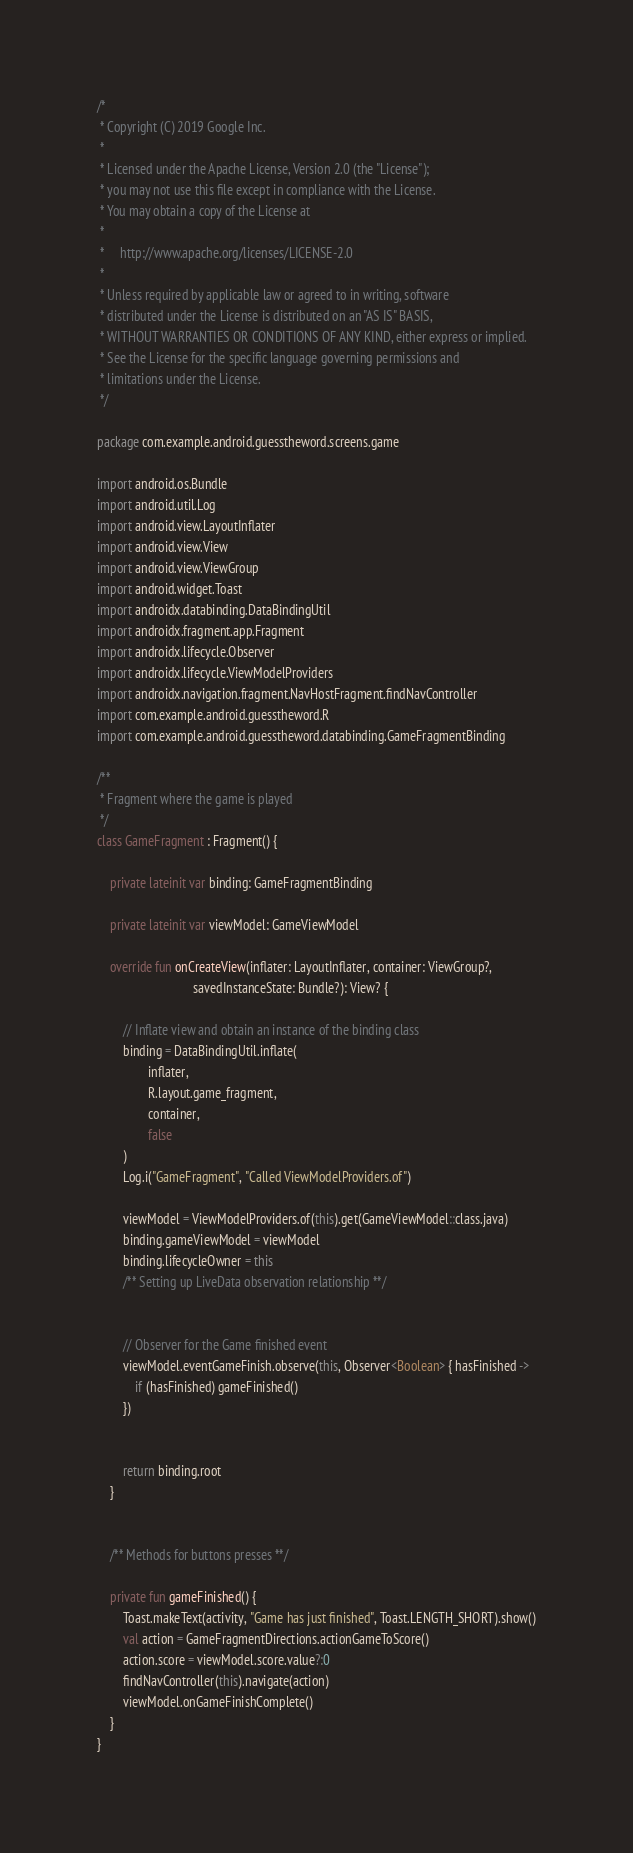Convert code to text. <code><loc_0><loc_0><loc_500><loc_500><_Kotlin_>/*
 * Copyright (C) 2019 Google Inc.
 *
 * Licensed under the Apache License, Version 2.0 (the "License");
 * you may not use this file except in compliance with the License.
 * You may obtain a copy of the License at
 *
 *     http://www.apache.org/licenses/LICENSE-2.0
 *
 * Unless required by applicable law or agreed to in writing, software
 * distributed under the License is distributed on an "AS IS" BASIS,
 * WITHOUT WARRANTIES OR CONDITIONS OF ANY KIND, either express or implied.
 * See the License for the specific language governing permissions and
 * limitations under the License.
 */

package com.example.android.guesstheword.screens.game

import android.os.Bundle
import android.util.Log
import android.view.LayoutInflater
import android.view.View
import android.view.ViewGroup
import android.widget.Toast
import androidx.databinding.DataBindingUtil
import androidx.fragment.app.Fragment
import androidx.lifecycle.Observer
import androidx.lifecycle.ViewModelProviders
import androidx.navigation.fragment.NavHostFragment.findNavController
import com.example.android.guesstheword.R
import com.example.android.guesstheword.databinding.GameFragmentBinding

/**
 * Fragment where the game is played
 */
class GameFragment : Fragment() {

    private lateinit var binding: GameFragmentBinding

    private lateinit var viewModel: GameViewModel

    override fun onCreateView(inflater: LayoutInflater, container: ViewGroup?,
                              savedInstanceState: Bundle?): View? {

        // Inflate view and obtain an instance of the binding class
        binding = DataBindingUtil.inflate(
                inflater,
                R.layout.game_fragment,
                container,
                false
        )
        Log.i("GameFragment", "Called ViewModelProviders.of")

        viewModel = ViewModelProviders.of(this).get(GameViewModel::class.java)
        binding.gameViewModel = viewModel
        binding.lifecycleOwner = this
        /** Setting up LiveData observation relationship **/


        // Observer for the Game finished event
        viewModel.eventGameFinish.observe(this, Observer<Boolean> { hasFinished ->
            if (hasFinished) gameFinished()
        })


        return binding.root
    }


    /** Methods for buttons presses **/

    private fun gameFinished() {
        Toast.makeText(activity, "Game has just finished", Toast.LENGTH_SHORT).show()
        val action = GameFragmentDirections.actionGameToScore()
        action.score = viewModel.score.value?:0
        findNavController(this).navigate(action)
        viewModel.onGameFinishComplete()
    }
}
</code> 